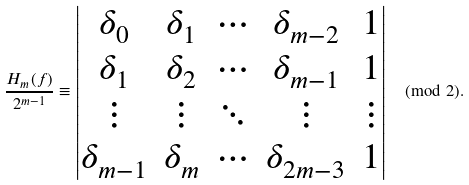<formula> <loc_0><loc_0><loc_500><loc_500>\frac { H _ { m } ( f ) } { 2 ^ { m - 1 } } \equiv \left | \begin{matrix} \delta _ { 0 } & \delta _ { 1 } & \cdots & \delta _ { m - 2 } & 1 \\ \delta _ { 1 } & \delta _ { 2 } & \cdots & \delta _ { m - 1 } & 1 \\ \vdots & \vdots & \ddots & \vdots & \vdots \\ \delta _ { m - 1 } & \delta _ { m } & \cdots & \delta _ { 2 m - 3 } & 1 \end{matrix} \right | \pmod { 2 } .</formula> 